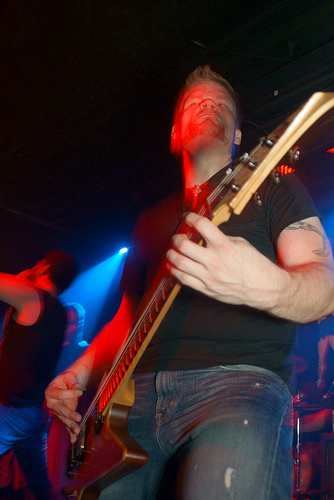<image>
Can you confirm if the guitar is in front of the man? Yes. The guitar is positioned in front of the man, appearing closer to the camera viewpoint. 